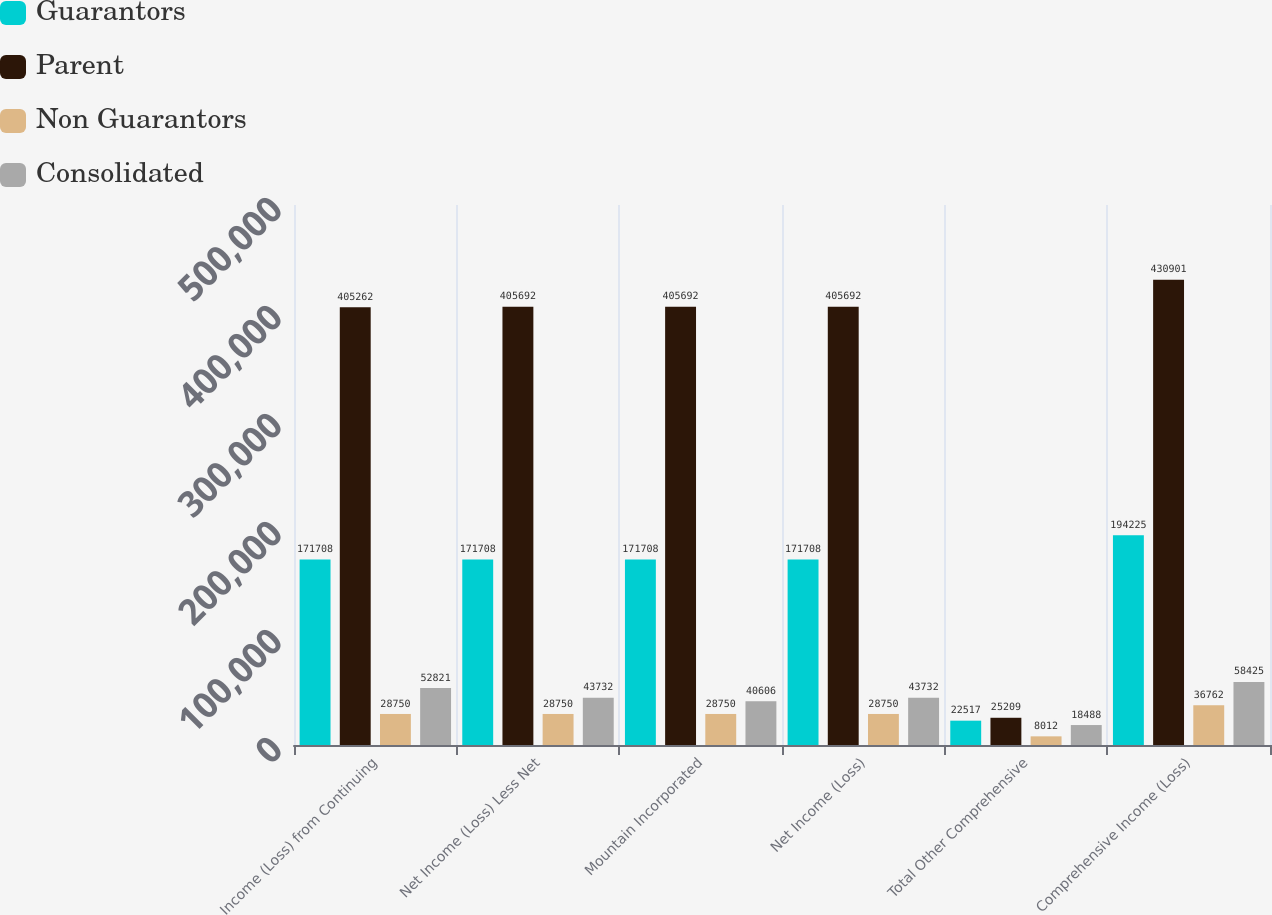Convert chart to OTSL. <chart><loc_0><loc_0><loc_500><loc_500><stacked_bar_chart><ecel><fcel>Income (Loss) from Continuing<fcel>Net Income (Loss) Less Net<fcel>Mountain Incorporated<fcel>Net Income (Loss)<fcel>Total Other Comprehensive<fcel>Comprehensive Income (Loss)<nl><fcel>Guarantors<fcel>171708<fcel>171708<fcel>171708<fcel>171708<fcel>22517<fcel>194225<nl><fcel>Parent<fcel>405262<fcel>405692<fcel>405692<fcel>405692<fcel>25209<fcel>430901<nl><fcel>Non Guarantors<fcel>28750<fcel>28750<fcel>28750<fcel>28750<fcel>8012<fcel>36762<nl><fcel>Consolidated<fcel>52821<fcel>43732<fcel>40606<fcel>43732<fcel>18488<fcel>58425<nl></chart> 